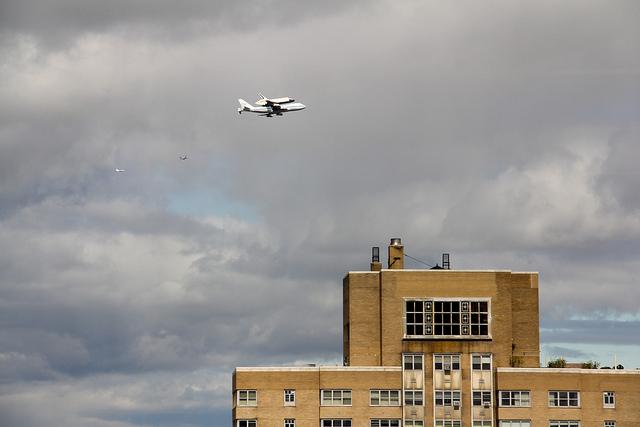Is there a clock in this photo?
Short answer required. No. Cloudy or sunny?
Quick response, please. Cloudy. Is this vehicle on the water?
Keep it brief. No. Are there clouds in the sky?
Answer briefly. Yes. Is the plane flying at a stable level?
Keep it brief. Yes. Are there people on the rooftops?
Write a very short answer. No. How tall is this building?
Concise answer only. 5 stories. Is it a nice day to fly kites?
Quick response, please. Yes. 